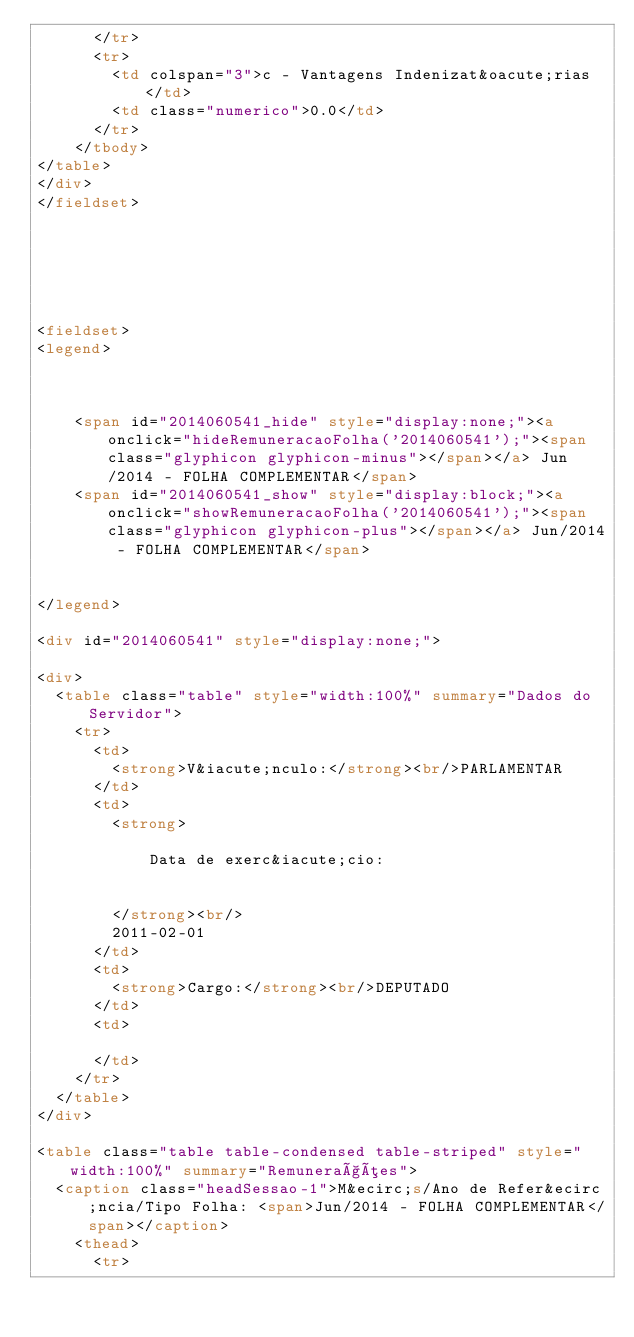<code> <loc_0><loc_0><loc_500><loc_500><_HTML_>			</tr>
			<tr>
				<td colspan="3">c - Vantagens Indenizat&oacute;rias</td>
				<td class="numerico">0.0</td>
			</tr>
		</tbody>
</table>
</div>
</fieldset>
	
			




<fieldset>
<legend>

	
	
		<span id="2014060541_hide" style="display:none;"><a onclick="hideRemuneracaoFolha('2014060541');"><span class="glyphicon glyphicon-minus"></span></a> Jun/2014 - FOLHA COMPLEMENTAR</span>
		<span id="2014060541_show" style="display:block;"><a onclick="showRemuneracaoFolha('2014060541');"><span class="glyphicon glyphicon-plus"></span></a> Jun/2014 - FOLHA COMPLEMENTAR</span>
	

</legend>

<div id="2014060541" style="display:none;">

<div>
	<table class="table" style="width:100%" summary="Dados do Servidor">
		<tr>
			<td>
				<strong>V&iacute;nculo:</strong><br/>PARLAMENTAR
			</td>
			<td>
				<strong>
					
						Data de exerc&iacute;cio:
						
					
				</strong><br/>
				2011-02-01
			</td>
			<td>
				<strong>Cargo:</strong><br/>DEPUTADO
			</td>
			<td>
			
			</td>
		</tr>
	</table>
</div>
					
<table class="table table-condensed table-striped" style="width:100%" summary="Remunerações">
	<caption class="headSessao-1">M&ecirc;s/Ano de Refer&ecirc;ncia/Tipo Folha: <span>Jun/2014 - FOLHA COMPLEMENTAR</span></caption>						
		<thead>
			<tr></code> 